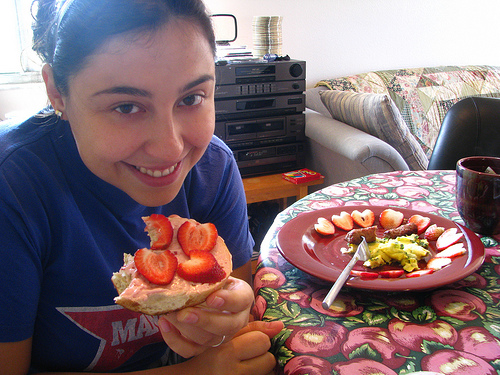<image>
Can you confirm if the plate is on the woman? No. The plate is not positioned on the woman. They may be near each other, but the plate is not supported by or resting on top of the woman. 